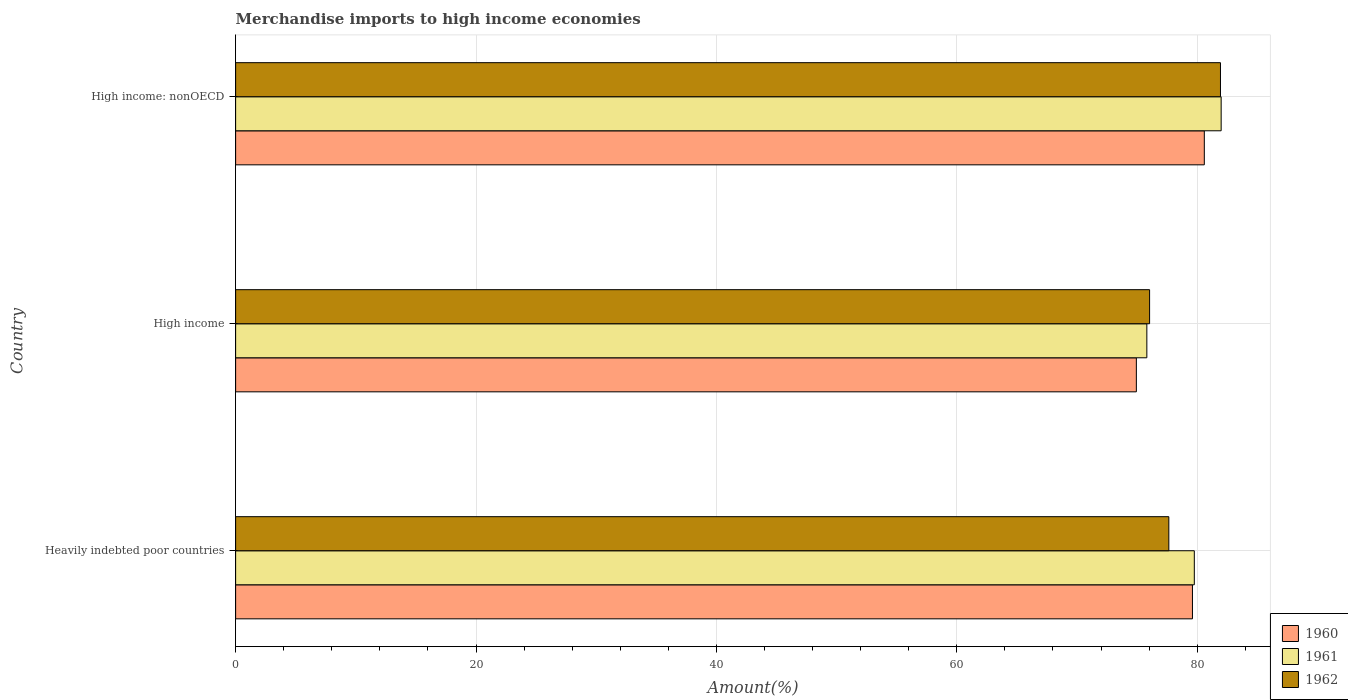How many different coloured bars are there?
Provide a short and direct response. 3. How many groups of bars are there?
Your response must be concise. 3. What is the label of the 2nd group of bars from the top?
Offer a terse response. High income. In how many cases, is the number of bars for a given country not equal to the number of legend labels?
Make the answer very short. 0. What is the percentage of amount earned from merchandise imports in 1962 in Heavily indebted poor countries?
Offer a very short reply. 77.64. Across all countries, what is the maximum percentage of amount earned from merchandise imports in 1960?
Keep it short and to the point. 80.59. Across all countries, what is the minimum percentage of amount earned from merchandise imports in 1960?
Provide a short and direct response. 74.94. In which country was the percentage of amount earned from merchandise imports in 1960 maximum?
Keep it short and to the point. High income: nonOECD. In which country was the percentage of amount earned from merchandise imports in 1962 minimum?
Ensure brevity in your answer.  High income. What is the total percentage of amount earned from merchandise imports in 1962 in the graph?
Give a very brief answer. 235.62. What is the difference between the percentage of amount earned from merchandise imports in 1962 in Heavily indebted poor countries and that in High income: nonOECD?
Give a very brief answer. -4.3. What is the difference between the percentage of amount earned from merchandise imports in 1961 in Heavily indebted poor countries and the percentage of amount earned from merchandise imports in 1960 in High income: nonOECD?
Make the answer very short. -0.83. What is the average percentage of amount earned from merchandise imports in 1961 per country?
Keep it short and to the point. 79.19. What is the difference between the percentage of amount earned from merchandise imports in 1960 and percentage of amount earned from merchandise imports in 1962 in Heavily indebted poor countries?
Your answer should be compact. 1.97. What is the ratio of the percentage of amount earned from merchandise imports in 1961 in Heavily indebted poor countries to that in High income: nonOECD?
Keep it short and to the point. 0.97. Is the difference between the percentage of amount earned from merchandise imports in 1960 in Heavily indebted poor countries and High income: nonOECD greater than the difference between the percentage of amount earned from merchandise imports in 1962 in Heavily indebted poor countries and High income: nonOECD?
Provide a short and direct response. Yes. What is the difference between the highest and the second highest percentage of amount earned from merchandise imports in 1962?
Your answer should be compact. 4.3. What is the difference between the highest and the lowest percentage of amount earned from merchandise imports in 1960?
Keep it short and to the point. 5.65. Is the sum of the percentage of amount earned from merchandise imports in 1960 in Heavily indebted poor countries and High income greater than the maximum percentage of amount earned from merchandise imports in 1961 across all countries?
Provide a short and direct response. Yes. What does the 2nd bar from the top in High income represents?
Your answer should be compact. 1961. What does the 1st bar from the bottom in Heavily indebted poor countries represents?
Offer a terse response. 1960. How many countries are there in the graph?
Offer a very short reply. 3. What is the difference between two consecutive major ticks on the X-axis?
Ensure brevity in your answer.  20. What is the title of the graph?
Offer a terse response. Merchandise imports to high income economies. Does "2014" appear as one of the legend labels in the graph?
Provide a short and direct response. No. What is the label or title of the X-axis?
Offer a terse response. Amount(%). What is the Amount(%) of 1960 in Heavily indebted poor countries?
Ensure brevity in your answer.  79.61. What is the Amount(%) in 1961 in Heavily indebted poor countries?
Offer a terse response. 79.76. What is the Amount(%) in 1962 in Heavily indebted poor countries?
Make the answer very short. 77.64. What is the Amount(%) of 1960 in High income?
Your response must be concise. 74.94. What is the Amount(%) in 1961 in High income?
Your answer should be very brief. 75.81. What is the Amount(%) of 1962 in High income?
Make the answer very short. 76.04. What is the Amount(%) of 1960 in High income: nonOECD?
Offer a very short reply. 80.59. What is the Amount(%) in 1961 in High income: nonOECD?
Provide a short and direct response. 81.99. What is the Amount(%) of 1962 in High income: nonOECD?
Keep it short and to the point. 81.94. Across all countries, what is the maximum Amount(%) in 1960?
Offer a very short reply. 80.59. Across all countries, what is the maximum Amount(%) of 1961?
Your response must be concise. 81.99. Across all countries, what is the maximum Amount(%) of 1962?
Give a very brief answer. 81.94. Across all countries, what is the minimum Amount(%) of 1960?
Make the answer very short. 74.94. Across all countries, what is the minimum Amount(%) of 1961?
Give a very brief answer. 75.81. Across all countries, what is the minimum Amount(%) in 1962?
Your answer should be compact. 76.04. What is the total Amount(%) in 1960 in the graph?
Your answer should be compact. 235.14. What is the total Amount(%) of 1961 in the graph?
Your answer should be very brief. 237.57. What is the total Amount(%) of 1962 in the graph?
Offer a terse response. 235.62. What is the difference between the Amount(%) of 1960 in Heavily indebted poor countries and that in High income?
Give a very brief answer. 4.67. What is the difference between the Amount(%) in 1961 in Heavily indebted poor countries and that in High income?
Your answer should be compact. 3.95. What is the difference between the Amount(%) of 1962 in Heavily indebted poor countries and that in High income?
Make the answer very short. 1.6. What is the difference between the Amount(%) in 1960 in Heavily indebted poor countries and that in High income: nonOECD?
Your response must be concise. -0.99. What is the difference between the Amount(%) in 1961 in Heavily indebted poor countries and that in High income: nonOECD?
Provide a short and direct response. -2.23. What is the difference between the Amount(%) in 1962 in Heavily indebted poor countries and that in High income: nonOECD?
Your response must be concise. -4.3. What is the difference between the Amount(%) of 1960 in High income and that in High income: nonOECD?
Offer a terse response. -5.65. What is the difference between the Amount(%) in 1961 in High income and that in High income: nonOECD?
Provide a succinct answer. -6.18. What is the difference between the Amount(%) in 1962 in High income and that in High income: nonOECD?
Your answer should be very brief. -5.9. What is the difference between the Amount(%) of 1960 in Heavily indebted poor countries and the Amount(%) of 1961 in High income?
Give a very brief answer. 3.8. What is the difference between the Amount(%) of 1960 in Heavily indebted poor countries and the Amount(%) of 1962 in High income?
Your response must be concise. 3.57. What is the difference between the Amount(%) of 1961 in Heavily indebted poor countries and the Amount(%) of 1962 in High income?
Offer a terse response. 3.72. What is the difference between the Amount(%) of 1960 in Heavily indebted poor countries and the Amount(%) of 1961 in High income: nonOECD?
Keep it short and to the point. -2.39. What is the difference between the Amount(%) of 1960 in Heavily indebted poor countries and the Amount(%) of 1962 in High income: nonOECD?
Offer a very short reply. -2.33. What is the difference between the Amount(%) of 1961 in Heavily indebted poor countries and the Amount(%) of 1962 in High income: nonOECD?
Make the answer very short. -2.18. What is the difference between the Amount(%) of 1960 in High income and the Amount(%) of 1961 in High income: nonOECD?
Provide a short and direct response. -7.05. What is the difference between the Amount(%) in 1960 in High income and the Amount(%) in 1962 in High income: nonOECD?
Offer a very short reply. -7. What is the difference between the Amount(%) in 1961 in High income and the Amount(%) in 1962 in High income: nonOECD?
Give a very brief answer. -6.13. What is the average Amount(%) of 1960 per country?
Provide a short and direct response. 78.38. What is the average Amount(%) in 1961 per country?
Your response must be concise. 79.19. What is the average Amount(%) in 1962 per country?
Offer a terse response. 78.54. What is the difference between the Amount(%) in 1960 and Amount(%) in 1961 in Heavily indebted poor countries?
Provide a short and direct response. -0.15. What is the difference between the Amount(%) in 1960 and Amount(%) in 1962 in Heavily indebted poor countries?
Offer a terse response. 1.97. What is the difference between the Amount(%) in 1961 and Amount(%) in 1962 in Heavily indebted poor countries?
Give a very brief answer. 2.12. What is the difference between the Amount(%) in 1960 and Amount(%) in 1961 in High income?
Offer a very short reply. -0.87. What is the difference between the Amount(%) of 1960 and Amount(%) of 1962 in High income?
Your response must be concise. -1.1. What is the difference between the Amount(%) in 1961 and Amount(%) in 1962 in High income?
Ensure brevity in your answer.  -0.23. What is the difference between the Amount(%) of 1960 and Amount(%) of 1961 in High income: nonOECD?
Provide a short and direct response. -1.4. What is the difference between the Amount(%) of 1960 and Amount(%) of 1962 in High income: nonOECD?
Keep it short and to the point. -1.34. What is the difference between the Amount(%) in 1961 and Amount(%) in 1962 in High income: nonOECD?
Your answer should be compact. 0.06. What is the ratio of the Amount(%) in 1960 in Heavily indebted poor countries to that in High income?
Your response must be concise. 1.06. What is the ratio of the Amount(%) of 1961 in Heavily indebted poor countries to that in High income?
Give a very brief answer. 1.05. What is the ratio of the Amount(%) of 1962 in Heavily indebted poor countries to that in High income?
Provide a succinct answer. 1.02. What is the ratio of the Amount(%) in 1960 in Heavily indebted poor countries to that in High income: nonOECD?
Your answer should be very brief. 0.99. What is the ratio of the Amount(%) in 1961 in Heavily indebted poor countries to that in High income: nonOECD?
Provide a succinct answer. 0.97. What is the ratio of the Amount(%) of 1962 in Heavily indebted poor countries to that in High income: nonOECD?
Ensure brevity in your answer.  0.95. What is the ratio of the Amount(%) in 1960 in High income to that in High income: nonOECD?
Offer a terse response. 0.93. What is the ratio of the Amount(%) of 1961 in High income to that in High income: nonOECD?
Provide a succinct answer. 0.92. What is the ratio of the Amount(%) in 1962 in High income to that in High income: nonOECD?
Provide a succinct answer. 0.93. What is the difference between the highest and the second highest Amount(%) of 1960?
Give a very brief answer. 0.99. What is the difference between the highest and the second highest Amount(%) in 1961?
Keep it short and to the point. 2.23. What is the difference between the highest and the second highest Amount(%) in 1962?
Offer a terse response. 4.3. What is the difference between the highest and the lowest Amount(%) of 1960?
Give a very brief answer. 5.65. What is the difference between the highest and the lowest Amount(%) of 1961?
Keep it short and to the point. 6.18. What is the difference between the highest and the lowest Amount(%) in 1962?
Keep it short and to the point. 5.9. 